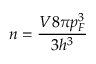<formula> <loc_0><loc_0><loc_500><loc_500>n = \frac { V 8 \pi p _ { F } ^ { 3 } } { 3 h ^ { 3 } }</formula> 